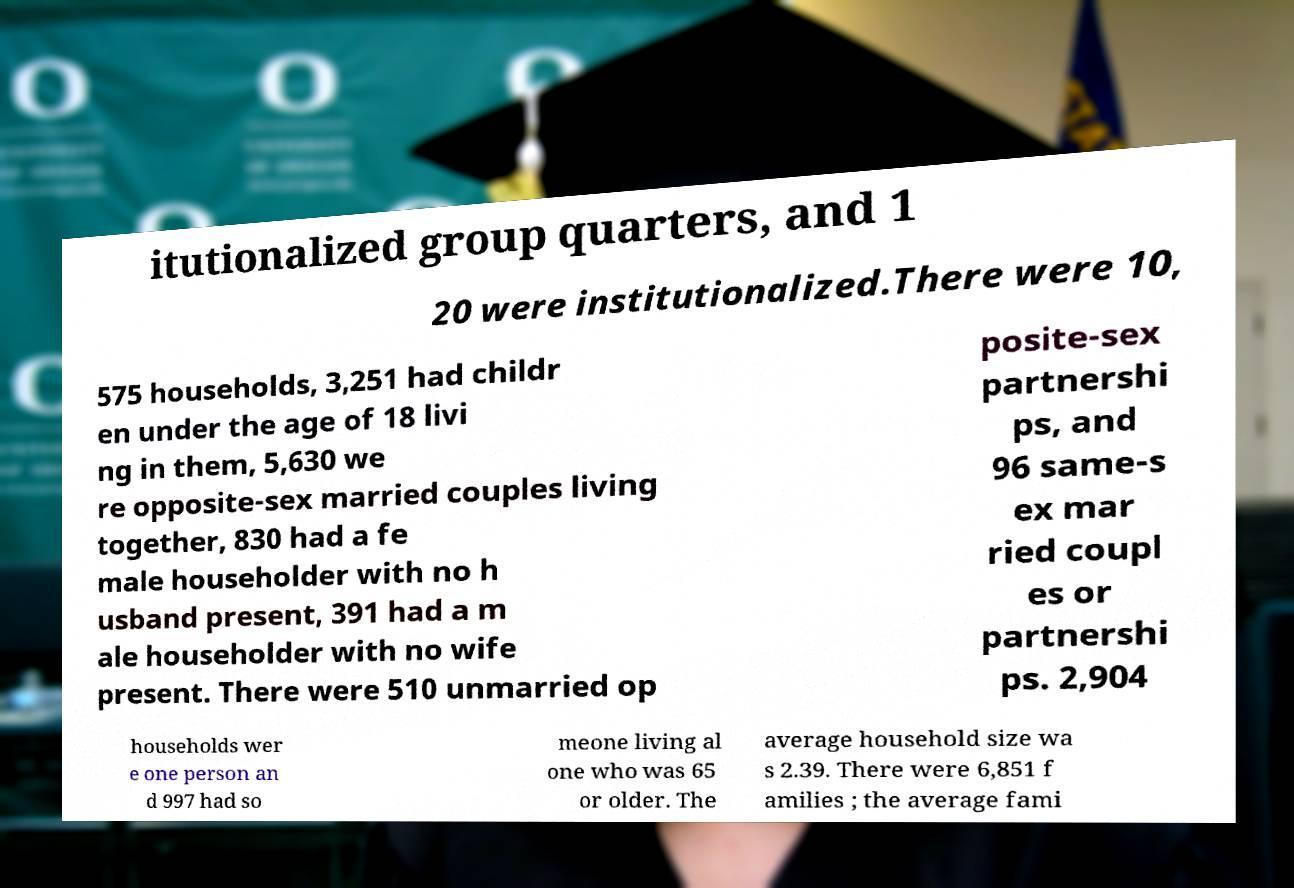I need the written content from this picture converted into text. Can you do that? itutionalized group quarters, and 1 20 were institutionalized.There were 10, 575 households, 3,251 had childr en under the age of 18 livi ng in them, 5,630 we re opposite-sex married couples living together, 830 had a fe male householder with no h usband present, 391 had a m ale householder with no wife present. There were 510 unmarried op posite-sex partnershi ps, and 96 same-s ex mar ried coupl es or partnershi ps. 2,904 households wer e one person an d 997 had so meone living al one who was 65 or older. The average household size wa s 2.39. There were 6,851 f amilies ; the average fami 